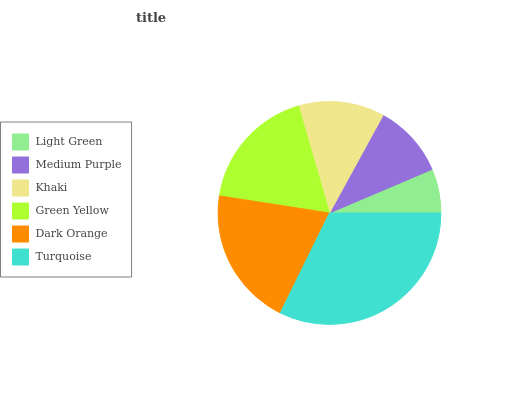Is Light Green the minimum?
Answer yes or no. Yes. Is Turquoise the maximum?
Answer yes or no. Yes. Is Medium Purple the minimum?
Answer yes or no. No. Is Medium Purple the maximum?
Answer yes or no. No. Is Medium Purple greater than Light Green?
Answer yes or no. Yes. Is Light Green less than Medium Purple?
Answer yes or no. Yes. Is Light Green greater than Medium Purple?
Answer yes or no. No. Is Medium Purple less than Light Green?
Answer yes or no. No. Is Green Yellow the high median?
Answer yes or no. Yes. Is Khaki the low median?
Answer yes or no. Yes. Is Turquoise the high median?
Answer yes or no. No. Is Dark Orange the low median?
Answer yes or no. No. 